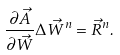Convert formula to latex. <formula><loc_0><loc_0><loc_500><loc_500>\frac { \partial \vec { A } } { \partial \vec { W } } \Delta \vec { W } ^ { n } = \vec { R } ^ { n } .</formula> 